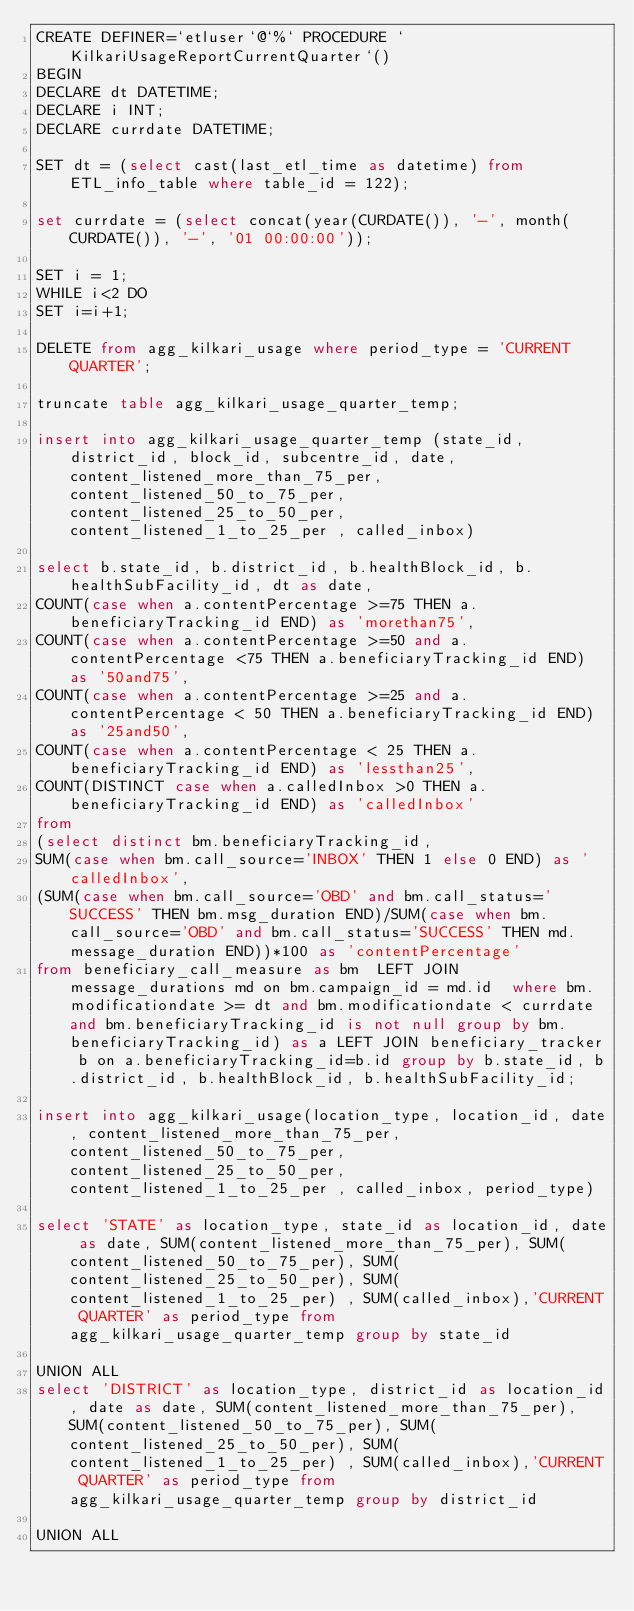<code> <loc_0><loc_0><loc_500><loc_500><_SQL_>CREATE DEFINER=`etluser`@`%` PROCEDURE `KilkariUsageReportCurrentQuarter`()
BEGIN
DECLARE dt DATETIME;
DECLARE i INT;
DECLARE currdate DATETIME;

SET dt = (select cast(last_etl_time as datetime) from ETL_info_table where table_id = 122);

set currdate = (select concat(year(CURDATE()), '-', month(CURDATE()), '-', '01 00:00:00'));

SET i = 1;
WHILE i<2 DO
SET i=i+1;

DELETE from agg_kilkari_usage where period_type = 'CURRENT QUARTER';

truncate table agg_kilkari_usage_quarter_temp;

insert into agg_kilkari_usage_quarter_temp (state_id, district_id, block_id, subcentre_id, date,  content_listened_more_than_75_per, content_listened_50_to_75_per, content_listened_25_to_50_per, content_listened_1_to_25_per , called_inbox) 

select b.state_id, b.district_id, b.healthBlock_id, b.healthSubFacility_id, dt as date, 
COUNT(case when a.contentPercentage >=75 THEN a.beneficiaryTracking_id END) as 'morethan75', 
COUNT(case when a.contentPercentage >=50 and a.contentPercentage <75 THEN a.beneficiaryTracking_id END) as '50and75', 
COUNT(case when a.contentPercentage >=25 and a.contentPercentage < 50 THEN a.beneficiaryTracking_id END) as '25and50', 
COUNT(case when a.contentPercentage < 25 THEN a.beneficiaryTracking_id END) as 'lessthan25',
COUNT(DISTINCT case when a.calledInbox >0 THEN a.beneficiaryTracking_id END) as 'calledInbox'
from 
(select distinct bm.beneficiaryTracking_id, 
SUM(case when bm.call_source='INBOX' THEN 1 else 0 END) as 'calledInbox', 
(SUM(case when bm.call_source='OBD' and bm.call_status='SUCCESS' THEN bm.msg_duration END)/SUM(case when bm.call_source='OBD' and bm.call_status='SUCCESS' THEN md.message_duration END))*100 as 'contentPercentage' 
from beneficiary_call_measure as bm  LEFT JOIN message_durations md on bm.campaign_id = md.id  where bm.modificationdate >= dt and bm.modificationdate < currdate and bm.beneficiaryTracking_id is not null group by bm.beneficiaryTracking_id) as a LEFT JOIN beneficiary_tracker b on a.beneficiaryTracking_id=b.id group by b.state_id, b.district_id, b.healthBlock_id, b.healthSubFacility_id;

insert into agg_kilkari_usage(location_type, location_id, date, content_listened_more_than_75_per, content_listened_50_to_75_per, content_listened_25_to_50_per, content_listened_1_to_25_per , called_inbox, period_type)

select 'STATE' as location_type, state_id as location_id, date as date, SUM(content_listened_more_than_75_per), SUM(content_listened_50_to_75_per), SUM(content_listened_25_to_50_per), SUM(content_listened_1_to_25_per) , SUM(called_inbox),'CURRENT QUARTER' as period_type from agg_kilkari_usage_quarter_temp group by state_id

UNION ALL
select 'DISTRICT' as location_type, district_id as location_id, date as date, SUM(content_listened_more_than_75_per), SUM(content_listened_50_to_75_per), SUM(content_listened_25_to_50_per), SUM(content_listened_1_to_25_per) , SUM(called_inbox),'CURRENT QUARTER' as period_type from agg_kilkari_usage_quarter_temp group by district_id

UNION ALL</code> 